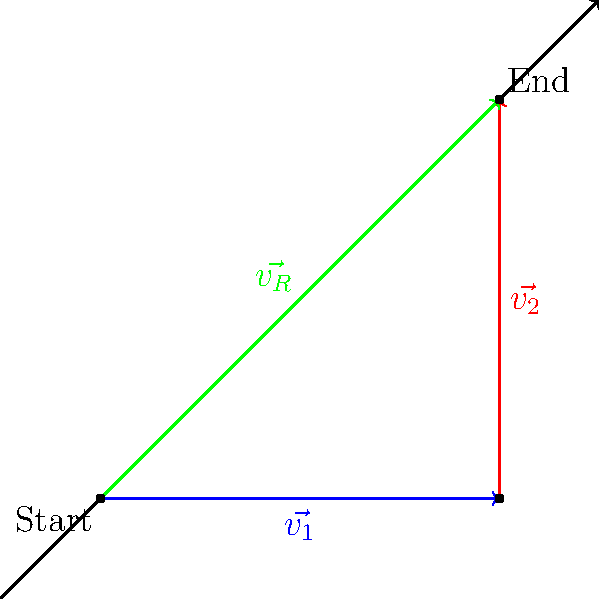During an air show, a stunt plane performs a series of maneuvers. It first flies 4 km east (represented by $\vec{v_1}$), then 4 km north (represented by $\vec{v_2}$). What is the magnitude of the resultant displacement vector $\vec{v_R}$ from the starting point to the final position? To solve this problem, we'll use vector addition and the Pythagorean theorem:

1) The two displacement vectors are:
   $\vec{v_1} = 4\hat{i}$ km (4 km east)
   $\vec{v_2} = 4\hat{j}$ km (4 km north)

2) The resultant vector $\vec{v_R}$ is the sum of these vectors:
   $\vec{v_R} = \vec{v_1} + \vec{v_2} = 4\hat{i} + 4\hat{j}$ km

3) To find the magnitude of $\vec{v_R}$, we use the Pythagorean theorem:
   $|\vec{v_R}| = \sqrt{(4)^2 + (4)^2}$ km

4) Simplify:
   $|\vec{v_R}| = \sqrt{16 + 16}$ km
   $|\vec{v_R}| = \sqrt{32}$ km
   $|\vec{v_R}| = 4\sqrt{2}$ km

Therefore, the magnitude of the resultant displacement vector is $4\sqrt{2}$ km.
Answer: $4\sqrt{2}$ km 